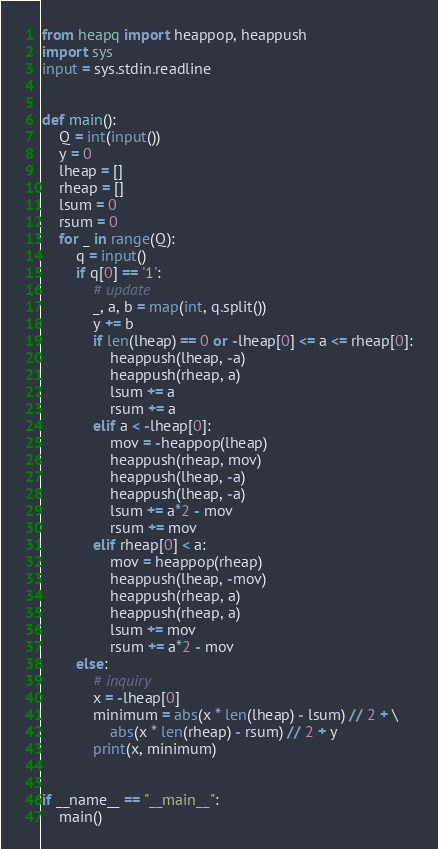Convert code to text. <code><loc_0><loc_0><loc_500><loc_500><_Python_>from heapq import heappop, heappush
import sys
input = sys.stdin.readline


def main():
    Q = int(input())
    y = 0
    lheap = []
    rheap = []
    lsum = 0
    rsum = 0
    for _ in range(Q):
        q = input()
        if q[0] == '1':
            # update
            _, a, b = map(int, q.split())
            y += b
            if len(lheap) == 0 or -lheap[0] <= a <= rheap[0]:
                heappush(lheap, -a)
                heappush(rheap, a)
                lsum += a
                rsum += a
            elif a < -lheap[0]:
                mov = -heappop(lheap)
                heappush(rheap, mov)
                heappush(lheap, -a)
                heappush(lheap, -a)
                lsum += a*2 - mov
                rsum += mov
            elif rheap[0] < a:
                mov = heappop(rheap)
                heappush(lheap, -mov)
                heappush(rheap, a)
                heappush(rheap, a)
                lsum += mov
                rsum += a*2 - mov
        else:
            # inquiry
            x = -lheap[0]
            minimum = abs(x * len(lheap) - lsum) // 2 + \
                abs(x * len(rheap) - rsum) // 2 + y
            print(x, minimum)


if __name__ == "__main__":
    main()
</code> 